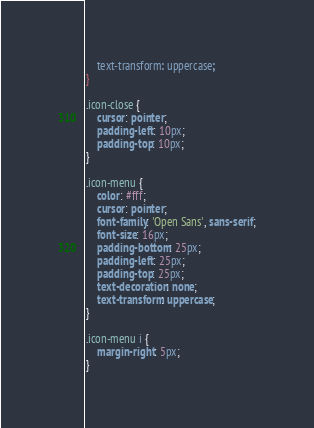<code> <loc_0><loc_0><loc_500><loc_500><_CSS_>    text-transform: uppercase;
}

.icon-close {
    cursor: pointer;
    padding-left: 10px;
    padding-top: 10px;
}

.icon-menu {
    color: #fff;
    cursor: pointer;
    font-family: 'Open Sans', sans-serif;
    font-size: 16px;
    padding-bottom: 25px;
    padding-left: 25px;
    padding-top: 25px;
    text-decoration: none;
    text-transform: uppercase;
}

.icon-menu i {
    margin-right: 5px;
}</code> 